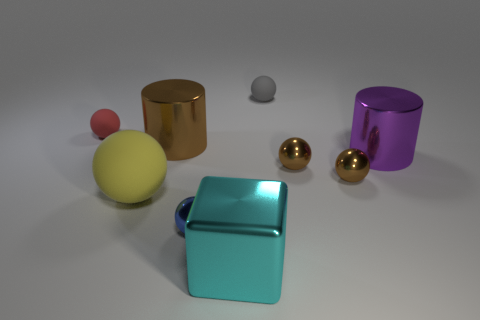Subtract all small red matte spheres. How many spheres are left? 5 Subtract all gray cylinders. How many brown balls are left? 2 Subtract all brown spheres. How many spheres are left? 4 Subtract all cyan balls. Subtract all red cubes. How many balls are left? 6 Subtract all tiny blue metal spheres. Subtract all large metal cubes. How many objects are left? 7 Add 7 tiny matte spheres. How many tiny matte spheres are left? 9 Add 2 brown things. How many brown things exist? 5 Subtract 0 green cubes. How many objects are left? 9 Subtract all cylinders. How many objects are left? 7 